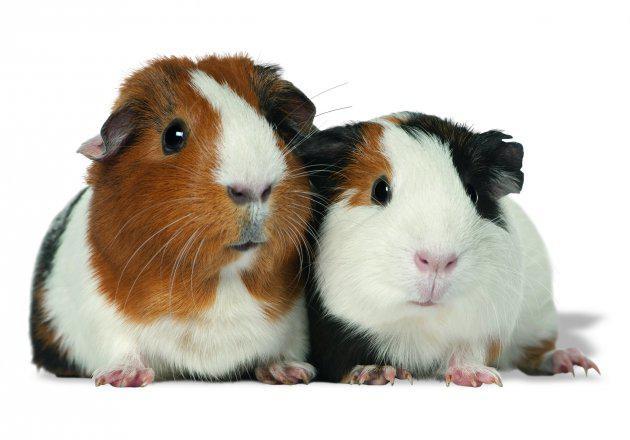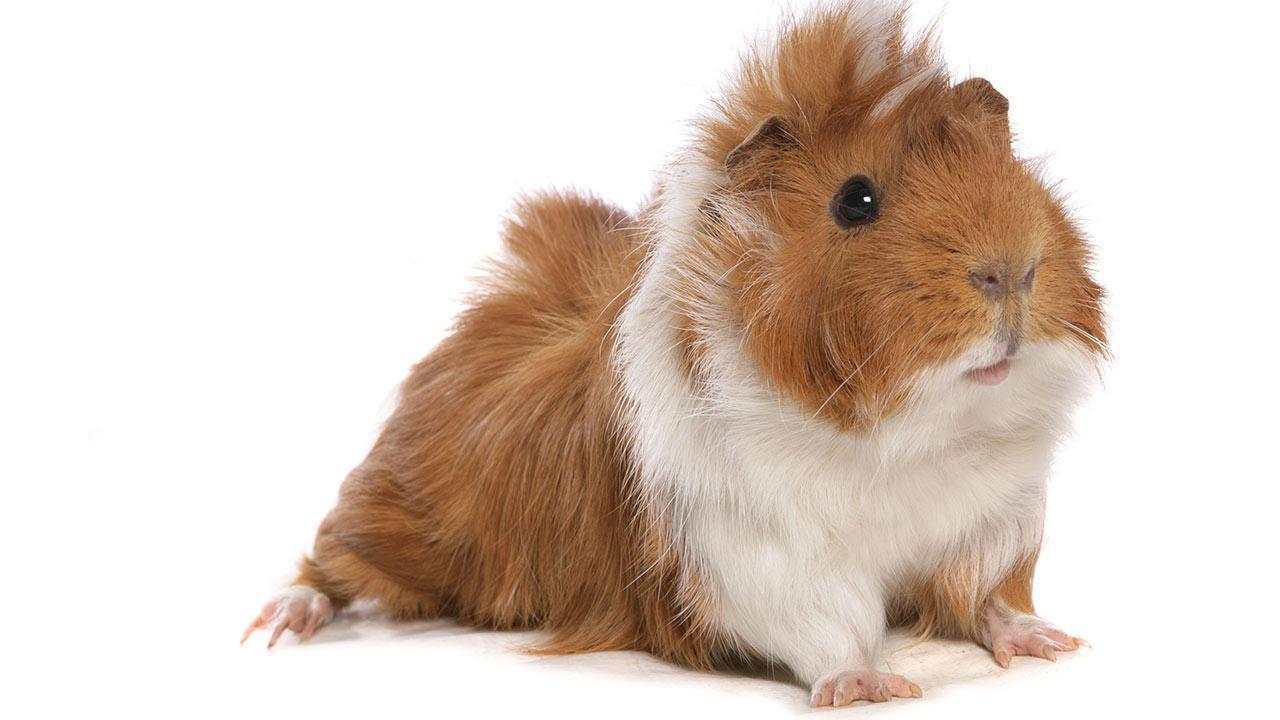The first image is the image on the left, the second image is the image on the right. Assess this claim about the two images: "In the left image, there are two guinea pigs". Correct or not? Answer yes or no. Yes. 